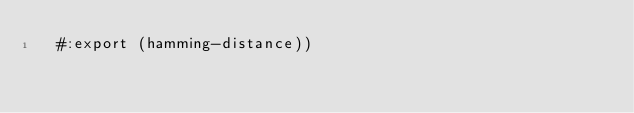<code> <loc_0><loc_0><loc_500><loc_500><_Scheme_>  #:export (hamming-distance))
</code> 